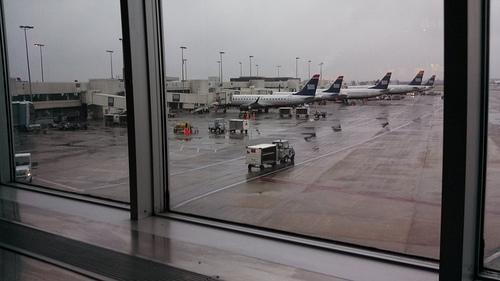How many planes are visible?
Give a very brief answer. 5. 